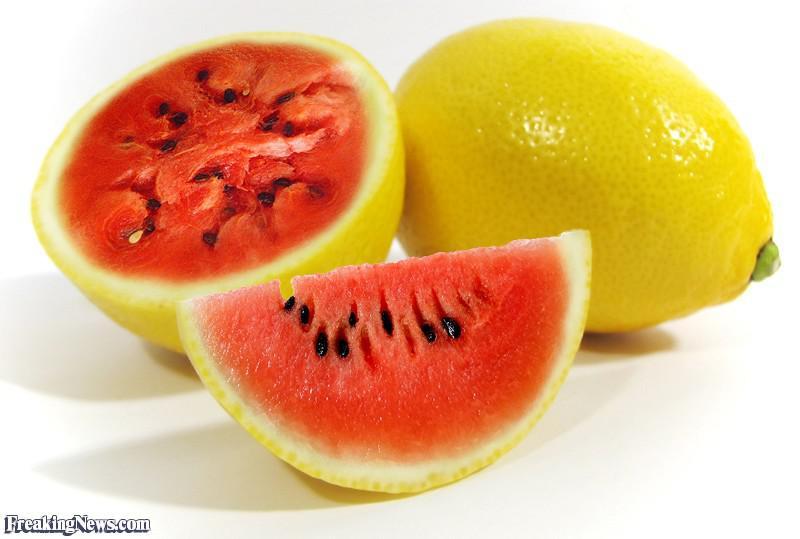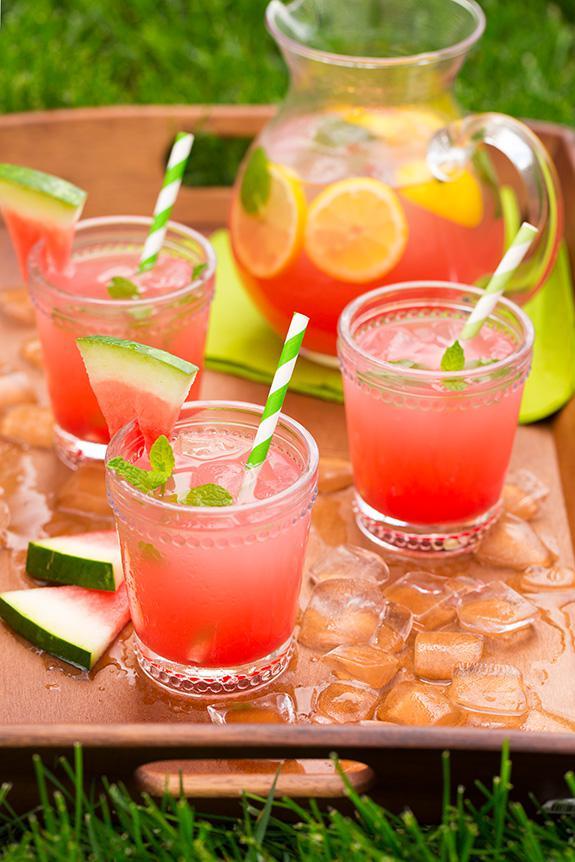The first image is the image on the left, the second image is the image on the right. Given the left and right images, does the statement "In one image, a red drink in a canning jar has at least one straw." hold true? Answer yes or no. No. The first image is the image on the left, the second image is the image on the right. For the images displayed, is the sentence "There is a straw with pink swirl in a drink." factually correct? Answer yes or no. No. 